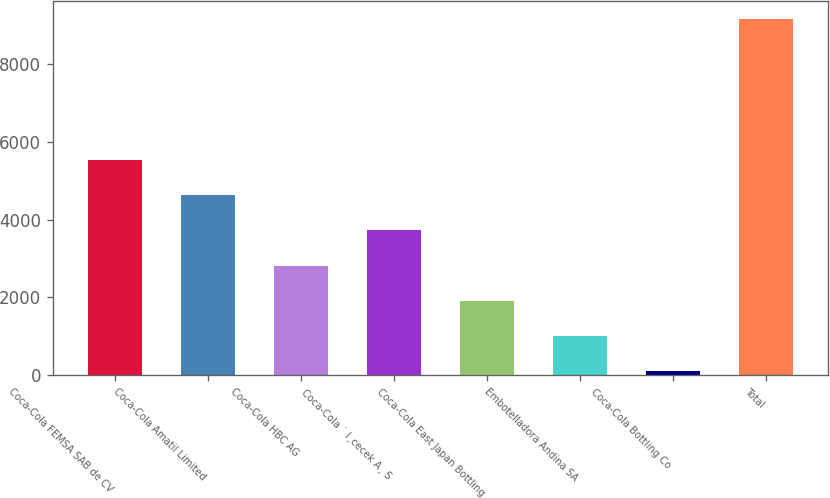<chart> <loc_0><loc_0><loc_500><loc_500><bar_chart><fcel>Coca-Cola FEMSA SAB de CV<fcel>Coca-Cola Amatil Limited<fcel>Coca-Cola HBC AG<fcel>Coca-Cola ˙ I¸cecek A¸ S<fcel>Coca-Cola East Japan Bottling<fcel>Embotelladora Andina SA<fcel>Coca-Cola Bottling Co<fcel>Total<nl><fcel>5531.8<fcel>4626<fcel>2814.4<fcel>3720.2<fcel>1908.6<fcel>1002.8<fcel>97<fcel>9155<nl></chart> 